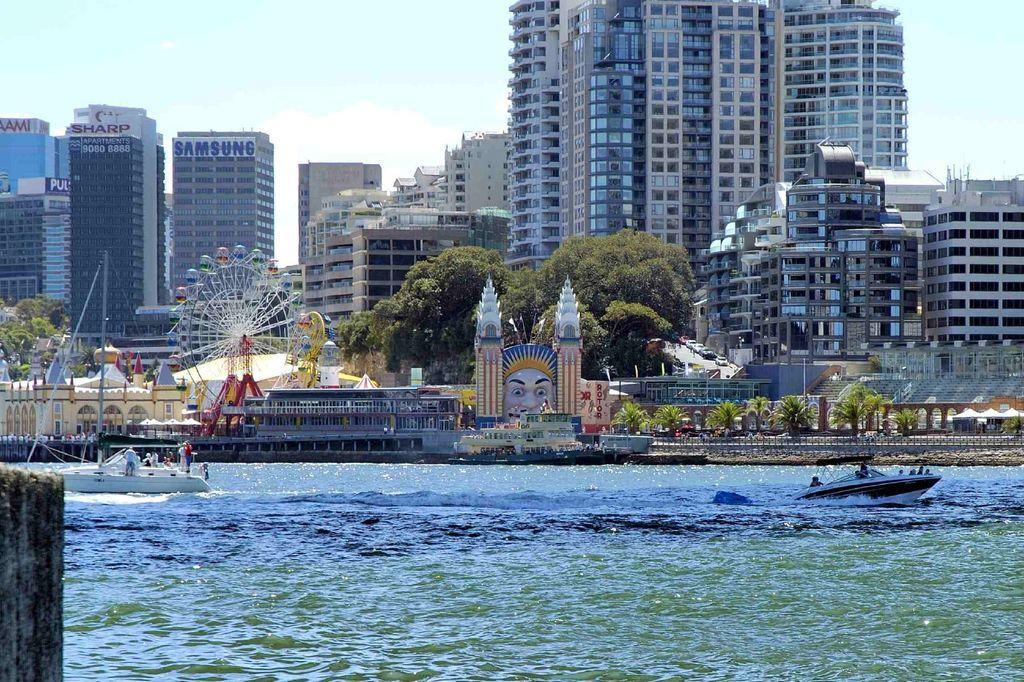Can you describe this image briefly? At the bottom of the picture, we see water and boats are sailing on the water. On the left side, we see a wooden stick. In the middle of the picture, we see trees, giant wheel and other games. There are trees and buildings in the background. At the top, we see the sky. 